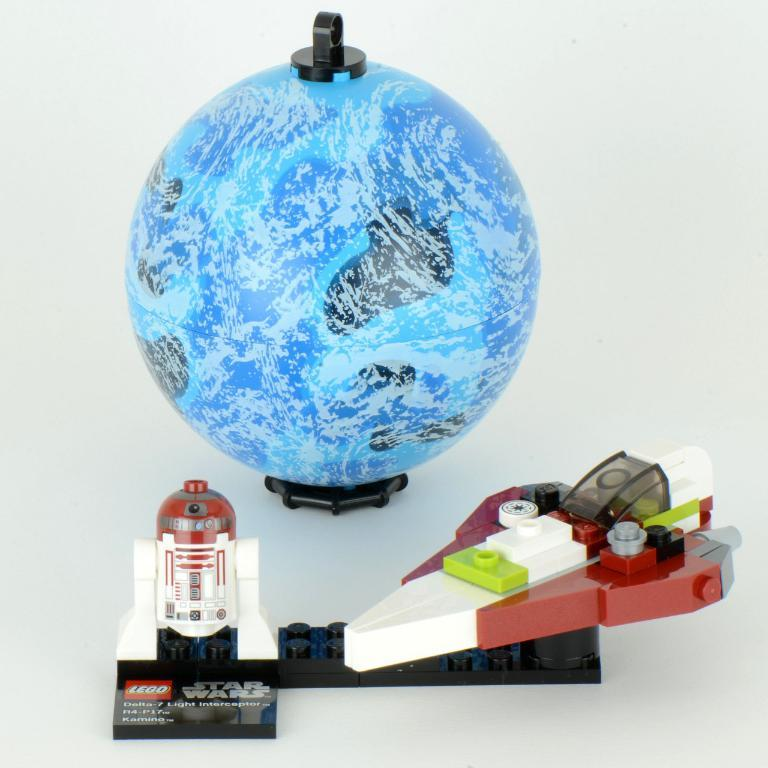What type of toy can be seen in the image? There is a toy rocket and a toy aircraft in the image. What other object is present in the image? There is a globe in the image. What type of clam is visible on the toy rocket in the image? There are no clams present on the toy rocket or any other object in the image. 